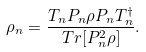Convert formula to latex. <formula><loc_0><loc_0><loc_500><loc_500>\rho _ { n } = \frac { T _ { n } P _ { n } \rho P _ { n } T _ { n } ^ { \dagger } } { T r [ P _ { n } ^ { 2 } \rho ] } .</formula> 